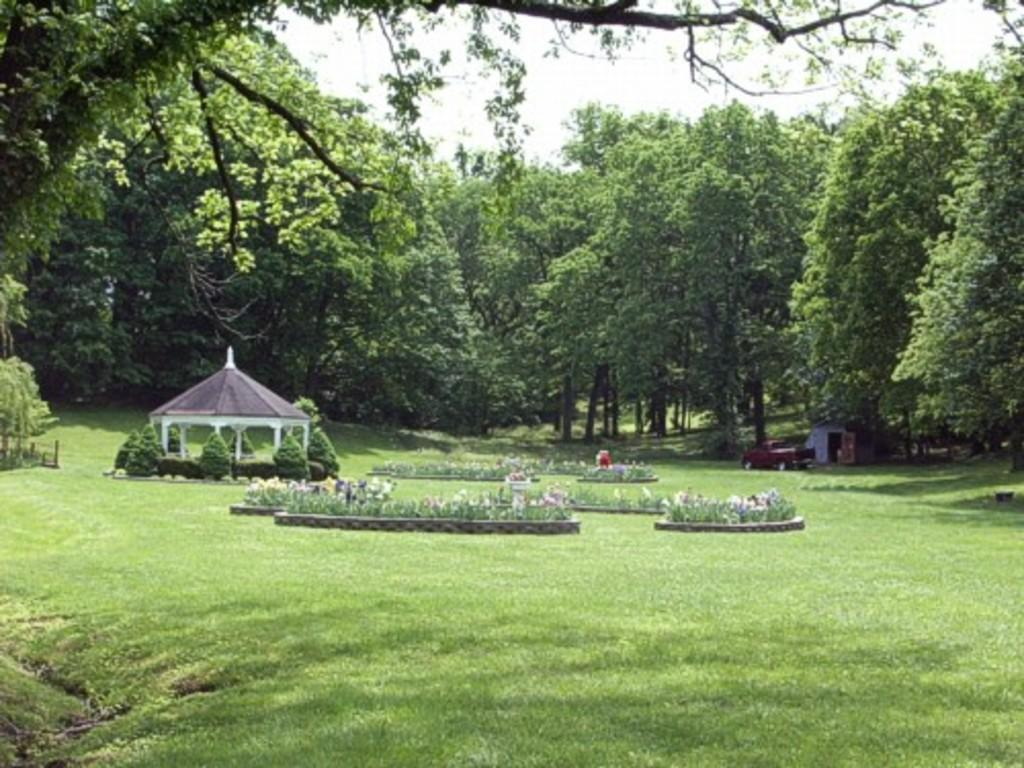What can be seen in the center of the image? The sky is visible in the center of the image. What is present in the sky? Clouds are present in the image. What type of vegetation can be seen in the image? Trees, grass, and plants are present in the image. How many vehicles are in the image? There is one vehicle in the image. How many houses are in the image? There is one house in the image. What kind of object resembles a tent in the image? There is a tent-type object in the image. Are there any other objects in the image besides the ones mentioned? Yes, there are a few other objects in the image. Can you tell me how many frogs are hopping around in the image? There are no frogs present in the image. What type of wind is blowing the zephyr in the image? There is no mention of a zephyr or any wind in the image. 